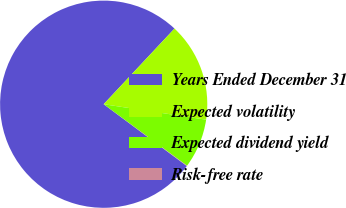Convert chart. <chart><loc_0><loc_0><loc_500><loc_500><pie_chart><fcel>Years Ended December 31<fcel>Expected volatility<fcel>Expected dividend yield<fcel>Risk-free rate<nl><fcel>76.8%<fcel>15.41%<fcel>7.73%<fcel>0.06%<nl></chart> 